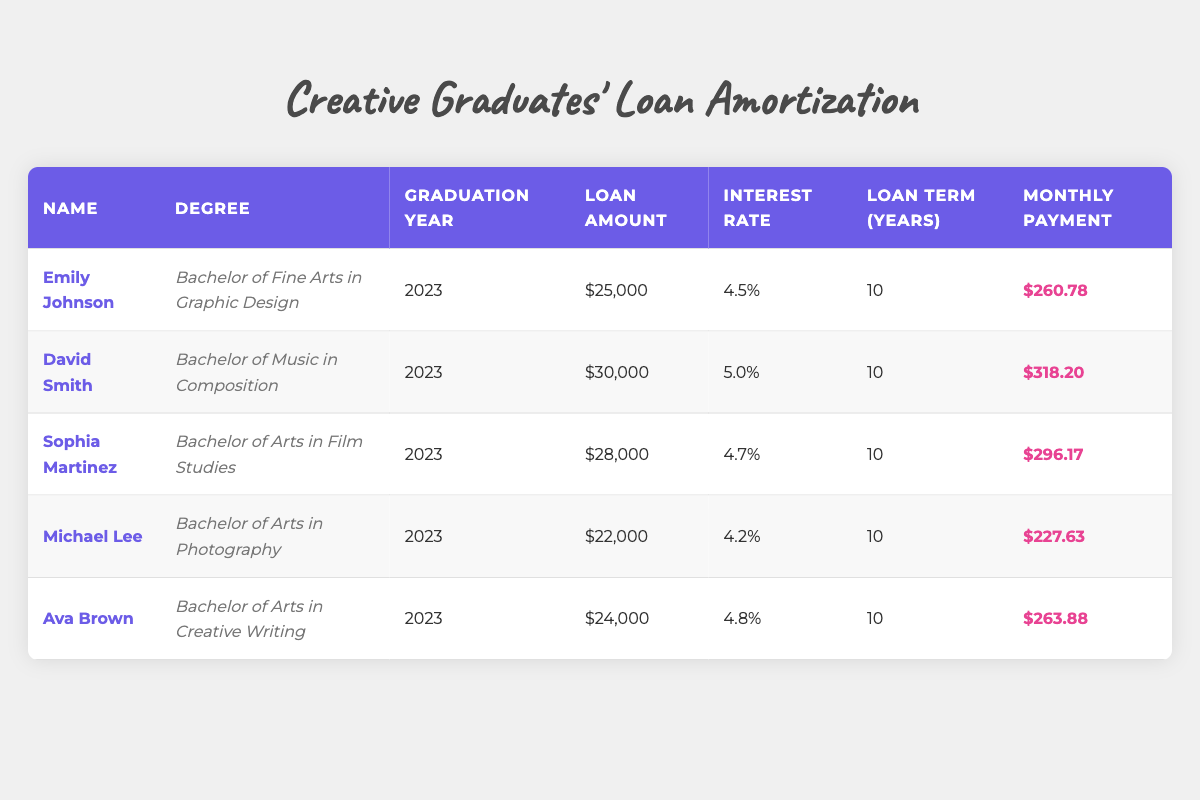What is the loan amount for Sophia Martinez? The table shows Sophia Martinez's loan amount listed under the "Loan Amount" column. It states that her loan amount is $28,000.
Answer: $28,000 Which graduate has the highest monthly payment? By looking at the "Monthly Payment" column for each graduate, we compare the values: Emily Johnson ($260.78), David Smith ($318.20), Sophia Martinez ($296.17), Michael Lee ($227.63), and Ava Brown ($263.88). The highest value is $318.20, which belongs to David Smith.
Answer: David Smith What is the average loan amount for all graduates? To find the average loan amount, we sum all the loan amounts: $25,000 + $30,000 + $28,000 + $22,000 + $24,000 = $129,000. Then, we divide it by the number of graduates, which is 5: $129,000 / 5 = $25,800.
Answer: $25,800 Did any graduate have a loan with an interest rate of less than 4.5%? We examine the "Interest Rate" column: Emily Johnson has 4.5%, David Smith has 5.0%, Sophia Martinez has 4.7%, Michael Lee has 4.2%, and Ava Brown has 4.8%. Since Michael Lee’s rate is 4.2%, the answer is yes.
Answer: Yes What is the total loan amount for graduates with a degree in a Bachelor of Arts? The graduates with a Bachelor of Arts are Sophia Martinez, Michael Lee, and Ava Brown. Their loan amounts are $28,000, $22,000, and $24,000 respectively. Summing these gives: $28,000 + $22,000 + $24,000 = $74,000.
Answer: $74,000 Which degree has the highest loan amount and what is that amount? The table lists the loan amounts for each degree. We look closely and find: Graphic Design - $25,000, Composition - $30,000, Film Studies - $28,000, Photography - $22,000, Creative Writing - $24,000. The highest amount is $30,000 for the degree in Music Composition.
Answer: Bachelor of Music in Composition; $30,000 What is the difference between the lowest and highest monthly payments? The lowest monthly payment is $227.63 for Michael Lee, and the highest is $318.20 for David Smith. To find the difference, we subtract the lowest from the highest: $318.20 - $227.63 = $90.57.
Answer: $90.57 Is there a graduate who has a loan term longer than 10 years? The table indicates all graduates have a loan term of 10 years. Since we are looking for any term longer than that, this is not found in the table.
Answer: No 